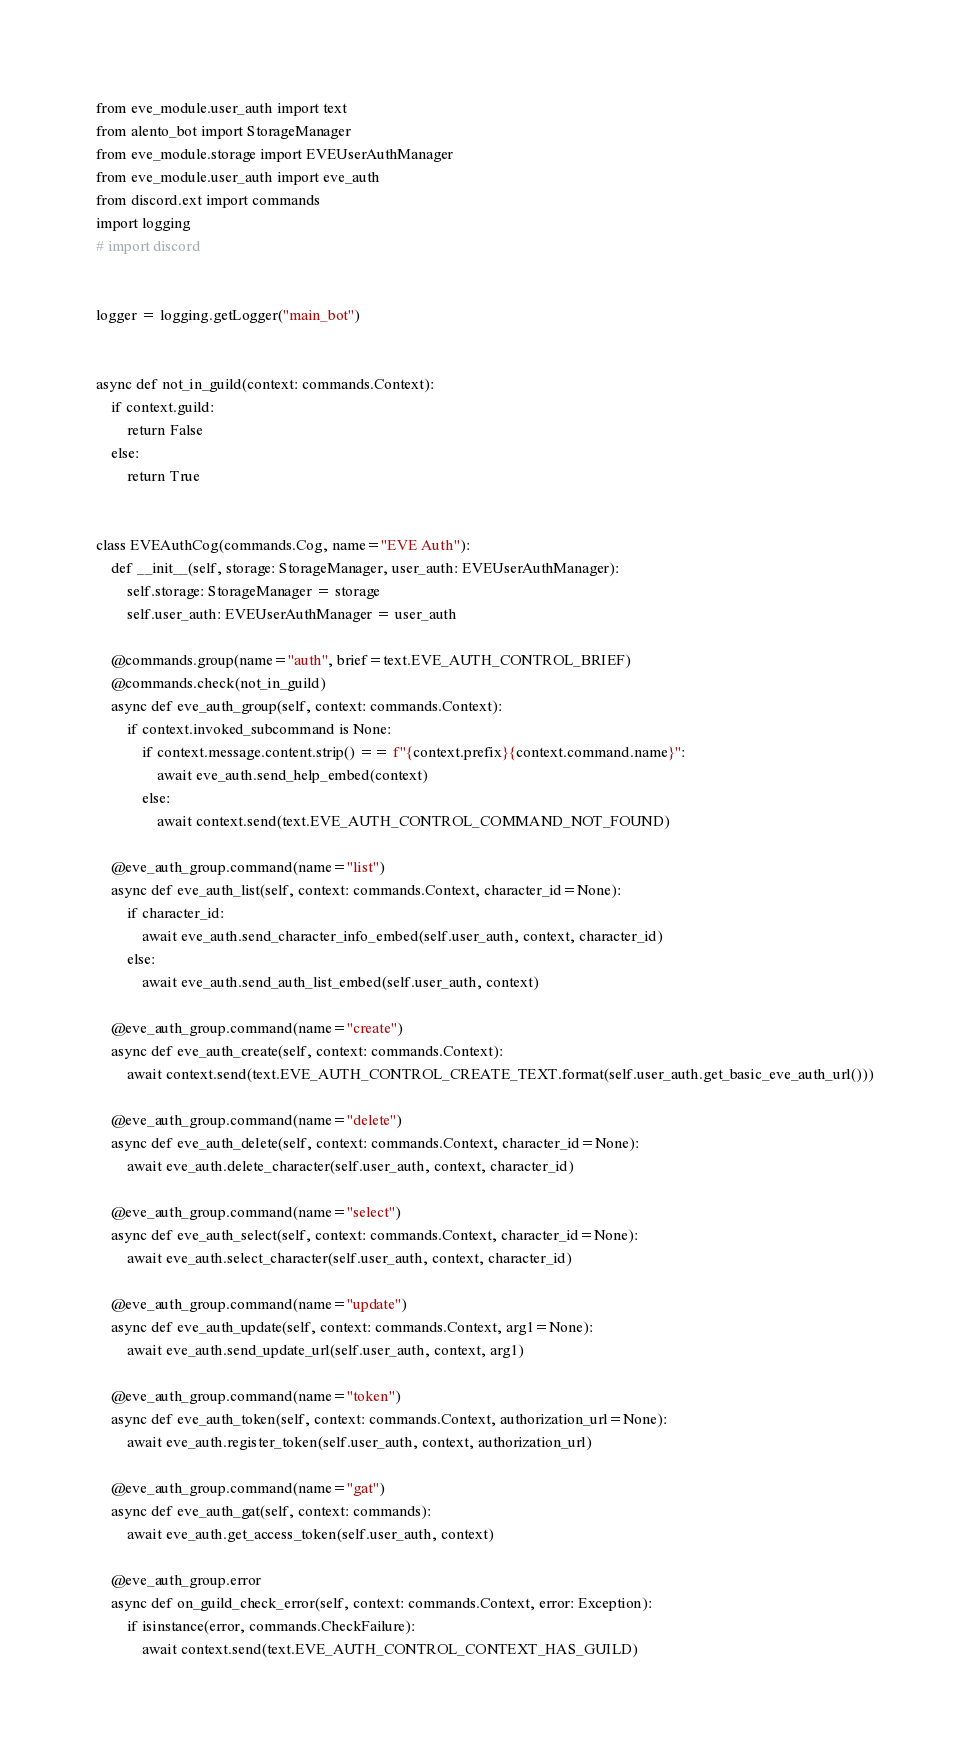Convert code to text. <code><loc_0><loc_0><loc_500><loc_500><_Python_>from eve_module.user_auth import text
from alento_bot import StorageManager
from eve_module.storage import EVEUserAuthManager
from eve_module.user_auth import eve_auth
from discord.ext import commands
import logging
# import discord


logger = logging.getLogger("main_bot")


async def not_in_guild(context: commands.Context):
    if context.guild:
        return False
    else:
        return True


class EVEAuthCog(commands.Cog, name="EVE Auth"):
    def __init__(self, storage: StorageManager, user_auth: EVEUserAuthManager):
        self.storage: StorageManager = storage
        self.user_auth: EVEUserAuthManager = user_auth

    @commands.group(name="auth", brief=text.EVE_AUTH_CONTROL_BRIEF)
    @commands.check(not_in_guild)
    async def eve_auth_group(self, context: commands.Context):
        if context.invoked_subcommand is None:
            if context.message.content.strip() == f"{context.prefix}{context.command.name}":
                await eve_auth.send_help_embed(context)
            else:
                await context.send(text.EVE_AUTH_CONTROL_COMMAND_NOT_FOUND)

    @eve_auth_group.command(name="list")
    async def eve_auth_list(self, context: commands.Context, character_id=None):
        if character_id:
            await eve_auth.send_character_info_embed(self.user_auth, context, character_id)
        else:
            await eve_auth.send_auth_list_embed(self.user_auth, context)

    @eve_auth_group.command(name="create")
    async def eve_auth_create(self, context: commands.Context):
        await context.send(text.EVE_AUTH_CONTROL_CREATE_TEXT.format(self.user_auth.get_basic_eve_auth_url()))

    @eve_auth_group.command(name="delete")
    async def eve_auth_delete(self, context: commands.Context, character_id=None):
        await eve_auth.delete_character(self.user_auth, context, character_id)

    @eve_auth_group.command(name="select")
    async def eve_auth_select(self, context: commands.Context, character_id=None):
        await eve_auth.select_character(self.user_auth, context, character_id)

    @eve_auth_group.command(name="update")
    async def eve_auth_update(self, context: commands.Context, arg1=None):
        await eve_auth.send_update_url(self.user_auth, context, arg1)

    @eve_auth_group.command(name="token")
    async def eve_auth_token(self, context: commands.Context, authorization_url=None):
        await eve_auth.register_token(self.user_auth, context, authorization_url)

    @eve_auth_group.command(name="gat")
    async def eve_auth_gat(self, context: commands):
        await eve_auth.get_access_token(self.user_auth, context)

    @eve_auth_group.error
    async def on_guild_check_error(self, context: commands.Context, error: Exception):
        if isinstance(error, commands.CheckFailure):
            await context.send(text.EVE_AUTH_CONTROL_CONTEXT_HAS_GUILD)
</code> 